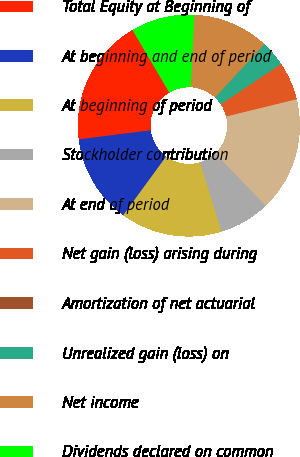Convert chart to OTSL. <chart><loc_0><loc_0><loc_500><loc_500><pie_chart><fcel>Total Equity at Beginning of<fcel>At beginning and end of period<fcel>At beginning of period<fcel>Stockholder contribution<fcel>At end of period<fcel>Net gain (loss) arising during<fcel>Amortization of net actuarial<fcel>Unrealized gain (loss) on<fcel>Net income<fcel>Dividends declared on common<nl><fcel>18.52%<fcel>12.96%<fcel>14.81%<fcel>7.41%<fcel>16.66%<fcel>5.56%<fcel>0.0%<fcel>3.71%<fcel>11.11%<fcel>9.26%<nl></chart> 